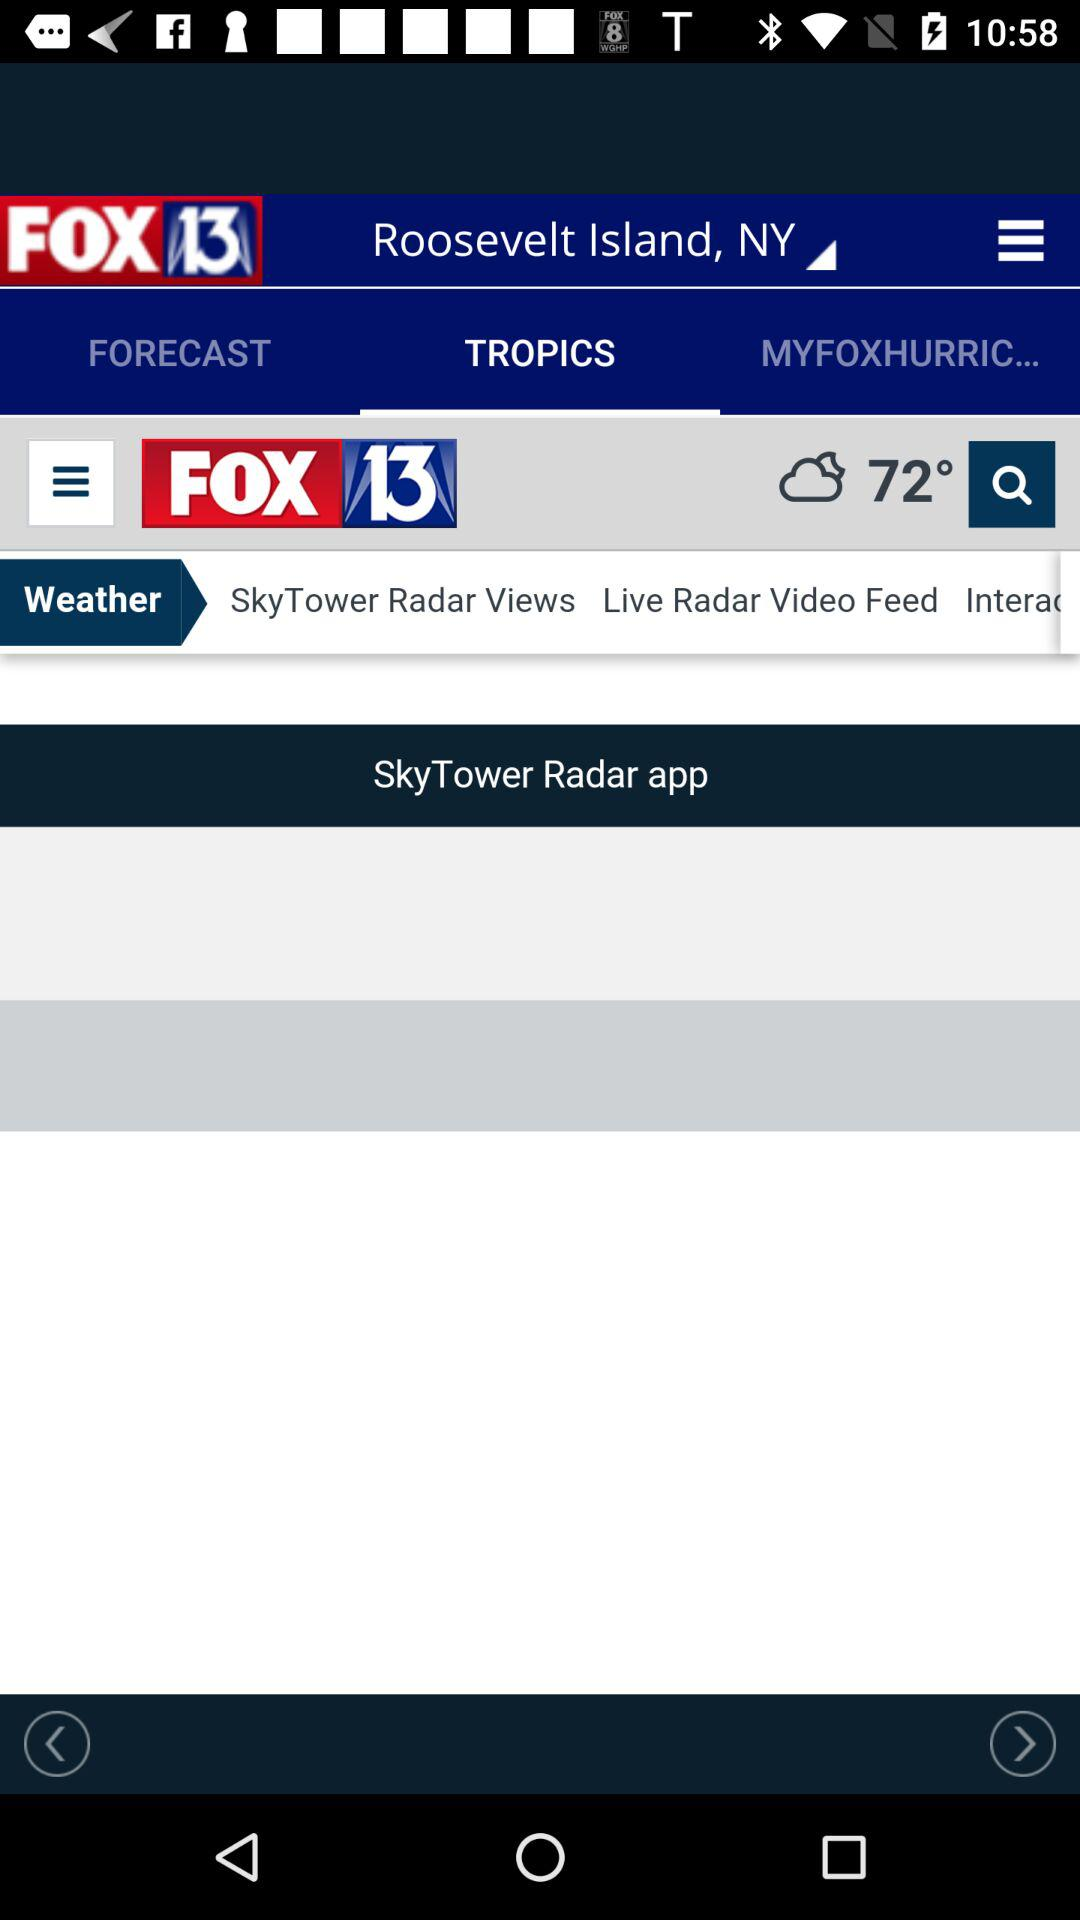What is the given location? The given location is Roosevelt Island, NY. 